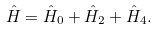Convert formula to latex. <formula><loc_0><loc_0><loc_500><loc_500>\hat { H } = \hat { H } _ { 0 } + \hat { H } _ { 2 } + \hat { H } _ { 4 } .</formula> 